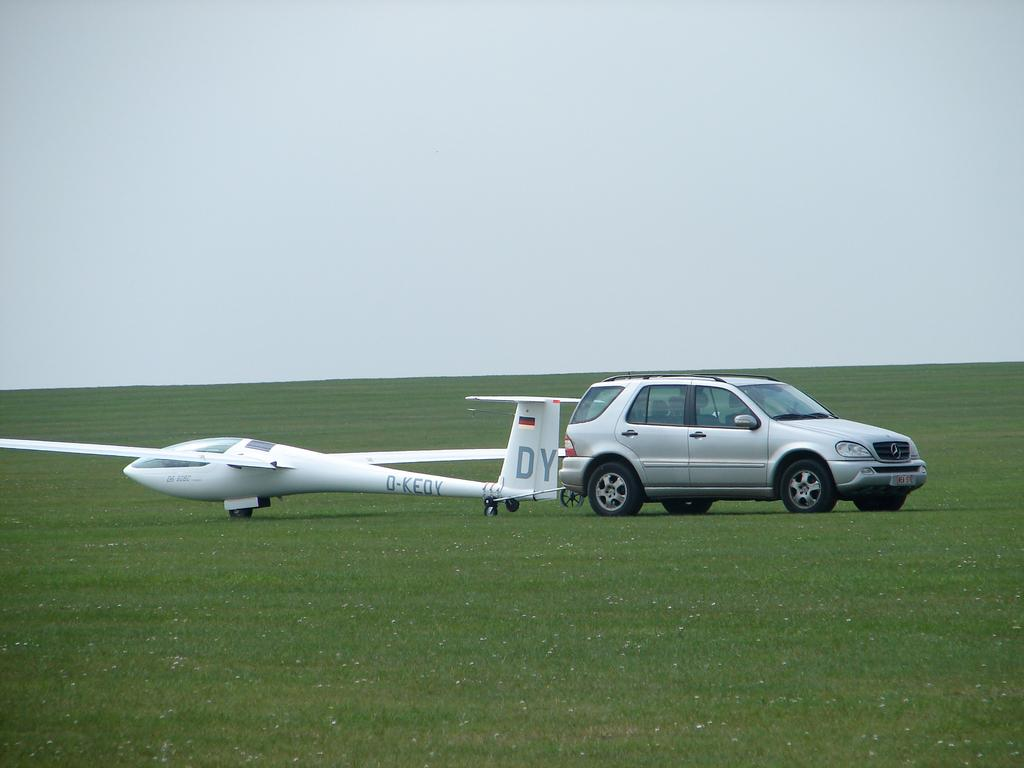<image>
Offer a succinct explanation of the picture presented. A silver car sits on field next to a small plane with DY on the tail. 